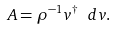Convert formula to latex. <formula><loc_0><loc_0><loc_500><loc_500>A = \rho ^ { - 1 } v ^ { \dagger } \ d v .</formula> 